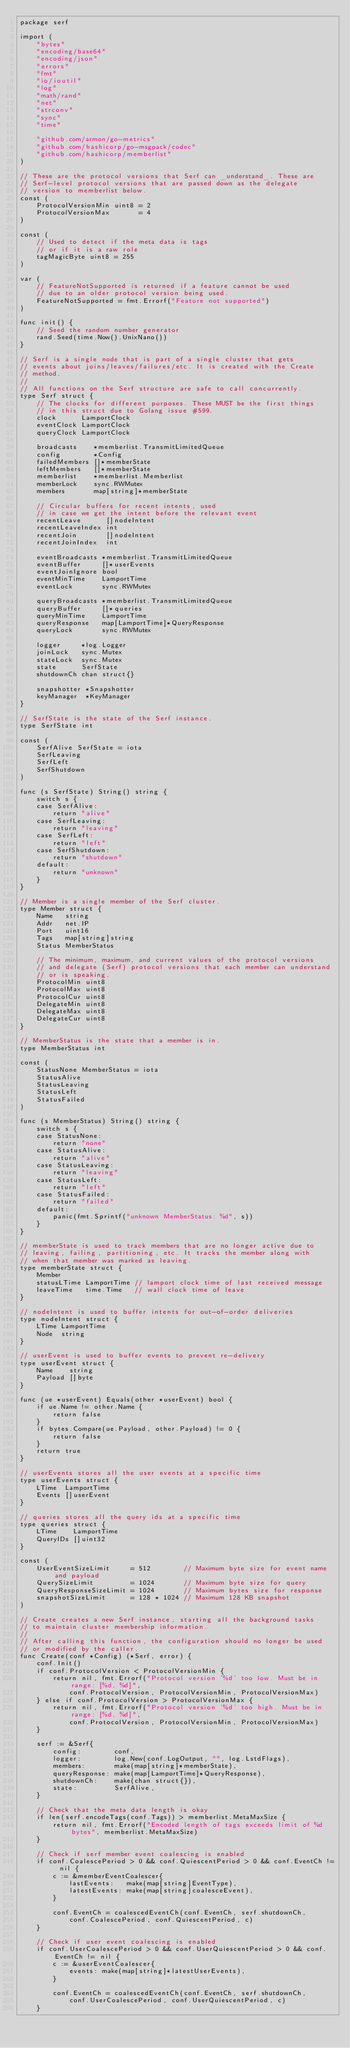Convert code to text. <code><loc_0><loc_0><loc_500><loc_500><_Go_>package serf

import (
	"bytes"
	"encoding/base64"
	"encoding/json"
	"errors"
	"fmt"
	"io/ioutil"
	"log"
	"math/rand"
	"net"
	"strconv"
	"sync"
	"time"

	"github.com/armon/go-metrics"
	"github.com/hashicorp/go-msgpack/codec"
	"github.com/hashicorp/memberlist"
)

// These are the protocol versions that Serf can _understand_. These are
// Serf-level protocol versions that are passed down as the delegate
// version to memberlist below.
const (
	ProtocolVersionMin uint8 = 2
	ProtocolVersionMax       = 4
)

const (
	// Used to detect if the meta data is tags
	// or if it is a raw role
	tagMagicByte uint8 = 255
)

var (
	// FeatureNotSupported is returned if a feature cannot be used
	// due to an older protocol version being used.
	FeatureNotSupported = fmt.Errorf("Feature not supported")
)

func init() {
	// Seed the random number generator
	rand.Seed(time.Now().UnixNano())
}

// Serf is a single node that is part of a single cluster that gets
// events about joins/leaves/failures/etc. It is created with the Create
// method.
//
// All functions on the Serf structure are safe to call concurrently.
type Serf struct {
	// The clocks for different purposes. These MUST be the first things
	// in this struct due to Golang issue #599.
	clock      LamportClock
	eventClock LamportClock
	queryClock LamportClock

	broadcasts    *memberlist.TransmitLimitedQueue
	config        *Config
	failedMembers []*memberState
	leftMembers   []*memberState
	memberlist    *memberlist.Memberlist
	memberLock    sync.RWMutex
	members       map[string]*memberState

	// Circular buffers for recent intents, used
	// in case we get the intent before the relevant event
	recentLeave      []nodeIntent
	recentLeaveIndex int
	recentJoin       []nodeIntent
	recentJoinIndex  int

	eventBroadcasts *memberlist.TransmitLimitedQueue
	eventBuffer     []*userEvents
	eventJoinIgnore bool
	eventMinTime    LamportTime
	eventLock       sync.RWMutex

	queryBroadcasts *memberlist.TransmitLimitedQueue
	queryBuffer     []*queries
	queryMinTime    LamportTime
	queryResponse   map[LamportTime]*QueryResponse
	queryLock       sync.RWMutex

	logger     *log.Logger
	joinLock   sync.Mutex
	stateLock  sync.Mutex
	state      SerfState
	shutdownCh chan struct{}

	snapshotter *Snapshotter
	keyManager  *KeyManager
}

// SerfState is the state of the Serf instance.
type SerfState int

const (
	SerfAlive SerfState = iota
	SerfLeaving
	SerfLeft
	SerfShutdown
)

func (s SerfState) String() string {
	switch s {
	case SerfAlive:
		return "alive"
	case SerfLeaving:
		return "leaving"
	case SerfLeft:
		return "left"
	case SerfShutdown:
		return "shutdown"
	default:
		return "unknown"
	}
}

// Member is a single member of the Serf cluster.
type Member struct {
	Name   string
	Addr   net.IP
	Port   uint16
	Tags   map[string]string
	Status MemberStatus

	// The minimum, maximum, and current values of the protocol versions
	// and delegate (Serf) protocol versions that each member can understand
	// or is speaking.
	ProtocolMin uint8
	ProtocolMax uint8
	ProtocolCur uint8
	DelegateMin uint8
	DelegateMax uint8
	DelegateCur uint8
}

// MemberStatus is the state that a member is in.
type MemberStatus int

const (
	StatusNone MemberStatus = iota
	StatusAlive
	StatusLeaving
	StatusLeft
	StatusFailed
)

func (s MemberStatus) String() string {
	switch s {
	case StatusNone:
		return "none"
	case StatusAlive:
		return "alive"
	case StatusLeaving:
		return "leaving"
	case StatusLeft:
		return "left"
	case StatusFailed:
		return "failed"
	default:
		panic(fmt.Sprintf("unknown MemberStatus: %d", s))
	}
}

// memberState is used to track members that are no longer active due to
// leaving, failing, partitioning, etc. It tracks the member along with
// when that member was marked as leaving.
type memberState struct {
	Member
	statusLTime LamportTime // lamport clock time of last received message
	leaveTime   time.Time   // wall clock time of leave
}

// nodeIntent is used to buffer intents for out-of-order deliveries
type nodeIntent struct {
	LTime LamportTime
	Node  string
}

// userEvent is used to buffer events to prevent re-delivery
type userEvent struct {
	Name    string
	Payload []byte
}

func (ue *userEvent) Equals(other *userEvent) bool {
	if ue.Name != other.Name {
		return false
	}
	if bytes.Compare(ue.Payload, other.Payload) != 0 {
		return false
	}
	return true
}

// userEvents stores all the user events at a specific time
type userEvents struct {
	LTime  LamportTime
	Events []userEvent
}

// queries stores all the query ids at a specific time
type queries struct {
	LTime    LamportTime
	QueryIDs []uint32
}

const (
	UserEventSizeLimit     = 512        // Maximum byte size for event name and payload
	QuerySizeLimit         = 1024       // Maximum byte size for query
	QueryResponseSizeLimit = 1024       // Maximum bytes size for response
	snapshotSizeLimit      = 128 * 1024 // Maximum 128 KB snapshot
)

// Create creates a new Serf instance, starting all the background tasks
// to maintain cluster membership information.
//
// After calling this function, the configuration should no longer be used
// or modified by the caller.
func Create(conf *Config) (*Serf, error) {
	conf.Init()
	if conf.ProtocolVersion < ProtocolVersionMin {
		return nil, fmt.Errorf("Protocol version '%d' too low. Must be in range: [%d, %d]",
			conf.ProtocolVersion, ProtocolVersionMin, ProtocolVersionMax)
	} else if conf.ProtocolVersion > ProtocolVersionMax {
		return nil, fmt.Errorf("Protocol version '%d' too high. Must be in range: [%d, %d]",
			conf.ProtocolVersion, ProtocolVersionMin, ProtocolVersionMax)
	}

	serf := &Serf{
		config:        conf,
		logger:        log.New(conf.LogOutput, "", log.LstdFlags),
		members:       make(map[string]*memberState),
		queryResponse: make(map[LamportTime]*QueryResponse),
		shutdownCh:    make(chan struct{}),
		state:         SerfAlive,
	}

	// Check that the meta data length is okay
	if len(serf.encodeTags(conf.Tags)) > memberlist.MetaMaxSize {
		return nil, fmt.Errorf("Encoded length of tags exceeds limit of %d bytes", memberlist.MetaMaxSize)
	}

	// Check if serf member event coalescing is enabled
	if conf.CoalescePeriod > 0 && conf.QuiescentPeriod > 0 && conf.EventCh != nil {
		c := &memberEventCoalescer{
			lastEvents:   make(map[string]EventType),
			latestEvents: make(map[string]coalesceEvent),
		}

		conf.EventCh = coalescedEventCh(conf.EventCh, serf.shutdownCh,
			conf.CoalescePeriod, conf.QuiescentPeriod, c)
	}

	// Check if user event coalescing is enabled
	if conf.UserCoalescePeriod > 0 && conf.UserQuiescentPeriod > 0 && conf.EventCh != nil {
		c := &userEventCoalescer{
			events: make(map[string]*latestUserEvents),
		}

		conf.EventCh = coalescedEventCh(conf.EventCh, serf.shutdownCh,
			conf.UserCoalescePeriod, conf.UserQuiescentPeriod, c)
	}
</code> 